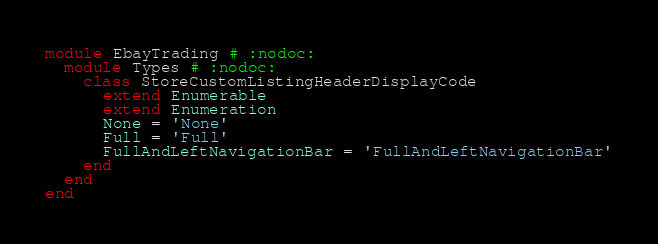<code> <loc_0><loc_0><loc_500><loc_500><_Ruby_>module EbayTrading # :nodoc:
  module Types # :nodoc:
    class StoreCustomListingHeaderDisplayCode
      extend Enumerable
      extend Enumeration
      None = 'None'
      Full = 'Full'
      FullAndLeftNavigationBar = 'FullAndLeftNavigationBar'
    end
  end
end

</code> 